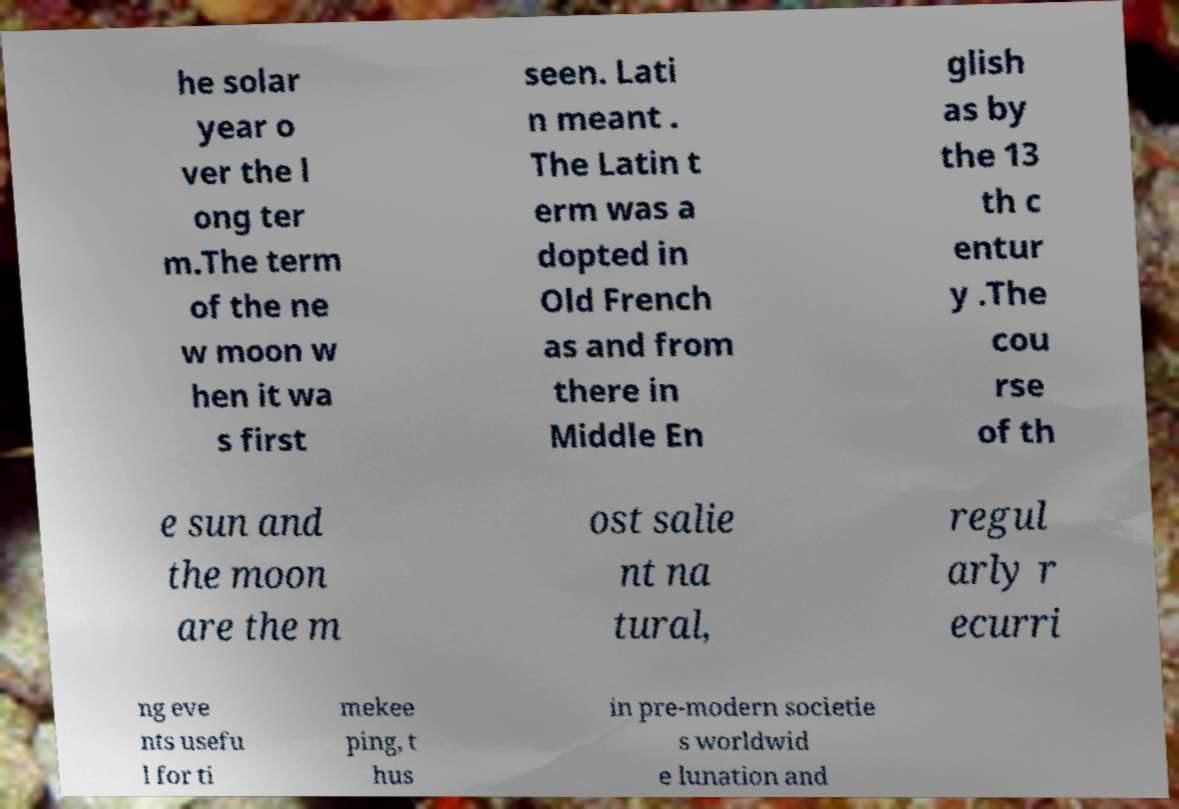There's text embedded in this image that I need extracted. Can you transcribe it verbatim? he solar year o ver the l ong ter m.The term of the ne w moon w hen it wa s first seen. Lati n meant . The Latin t erm was a dopted in Old French as and from there in Middle En glish as by the 13 th c entur y .The cou rse of th e sun and the moon are the m ost salie nt na tural, regul arly r ecurri ng eve nts usefu l for ti mekee ping, t hus in pre-modern societie s worldwid e lunation and 